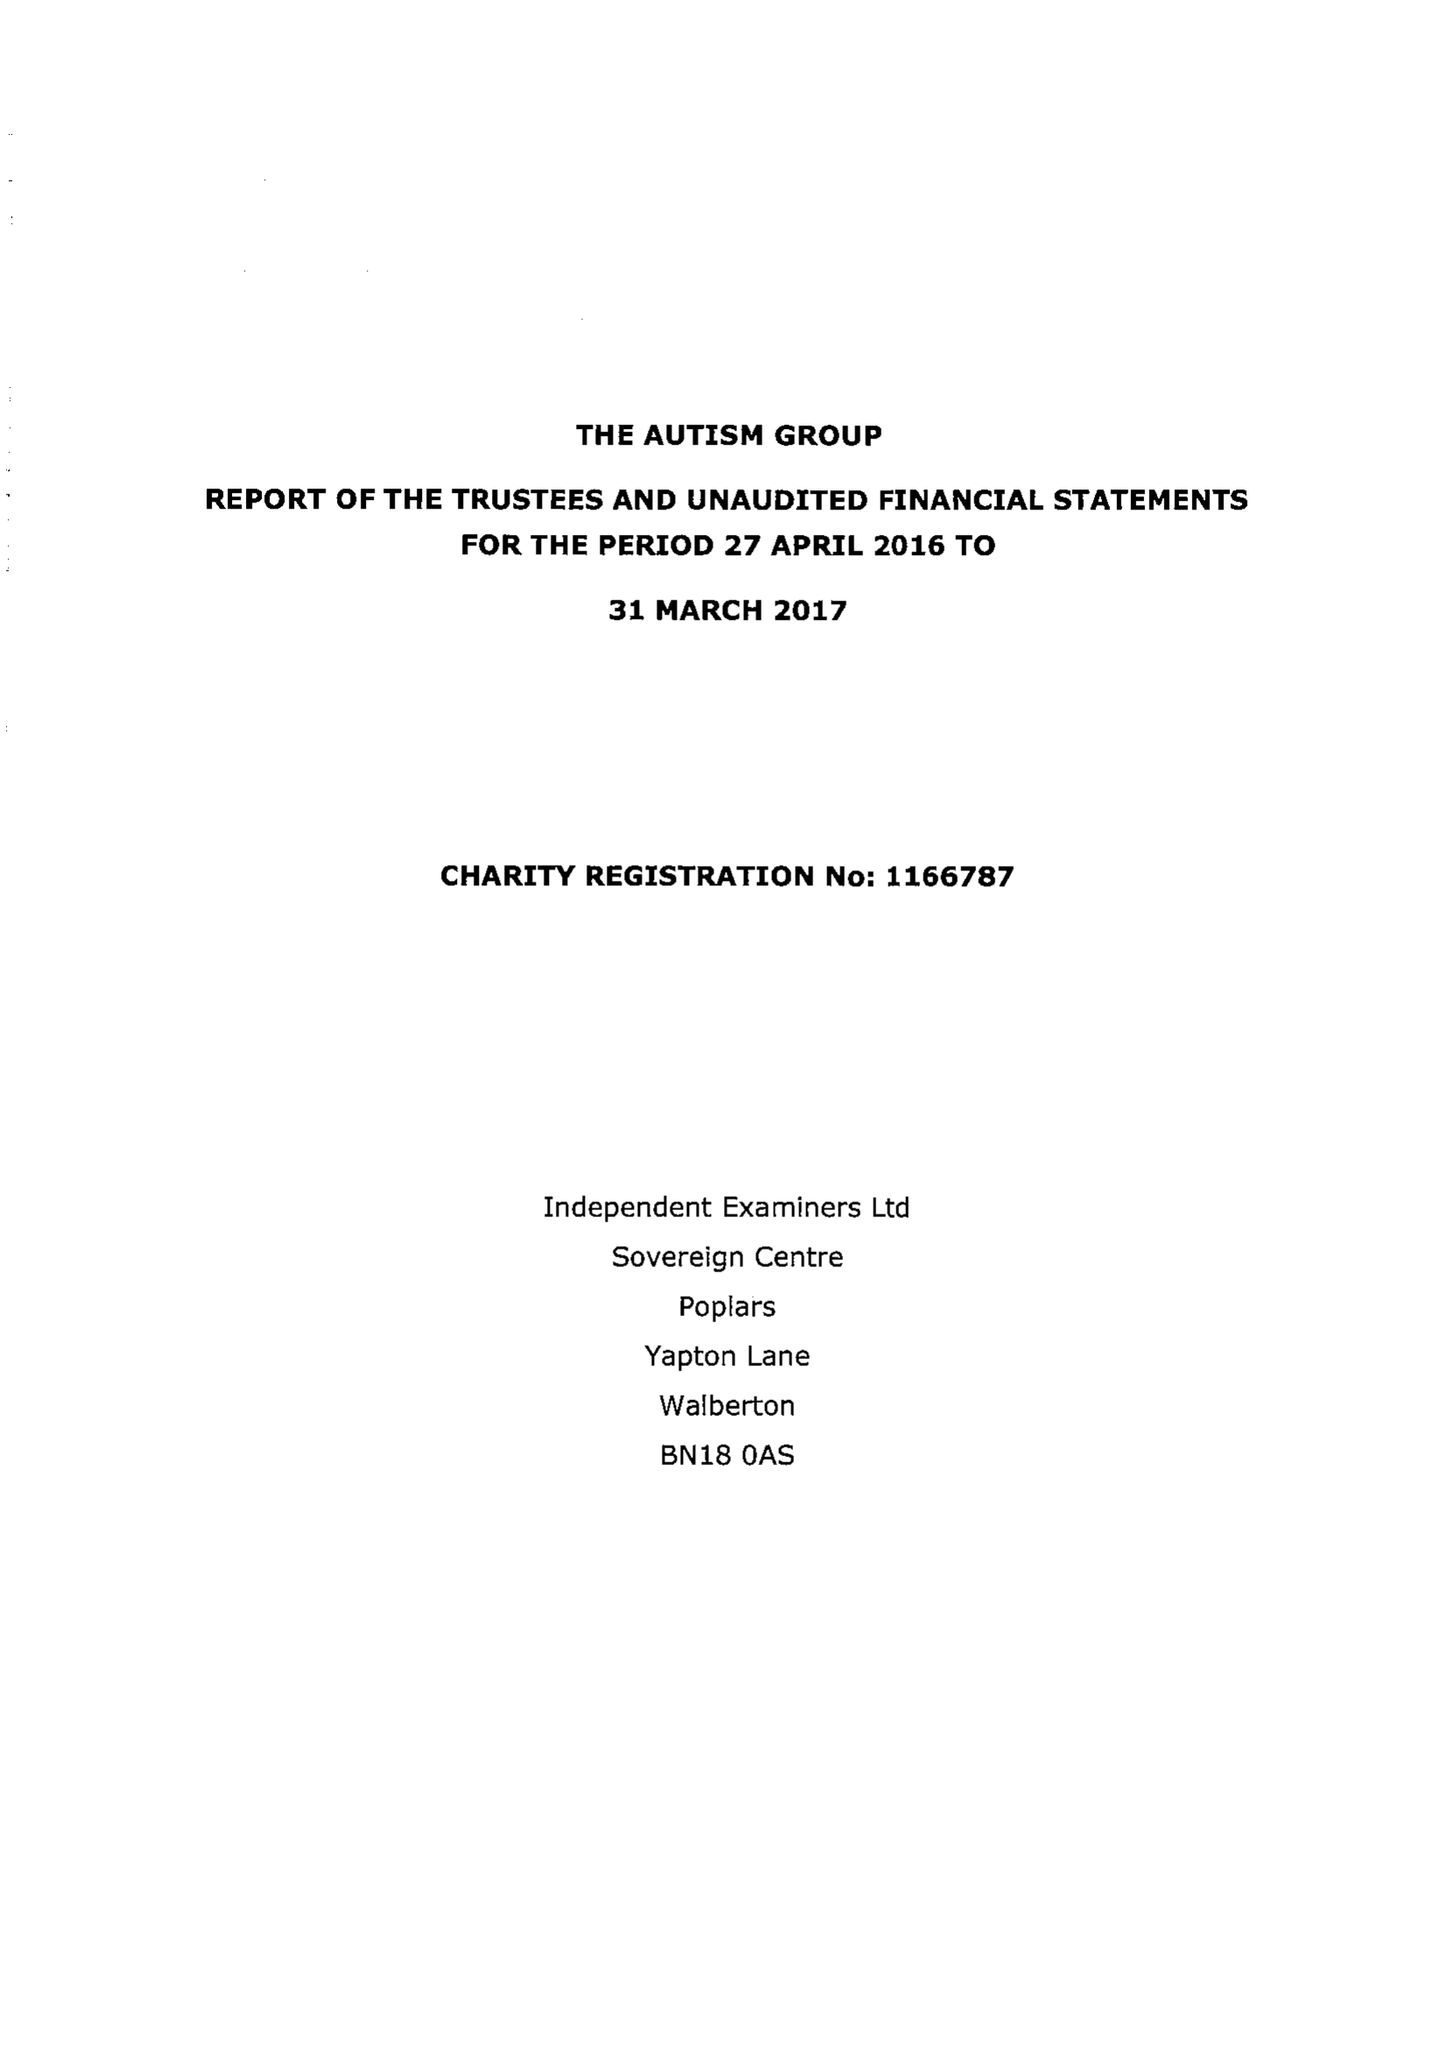What is the value for the address__postcode?
Answer the question using a single word or phrase. SL6 1LY 